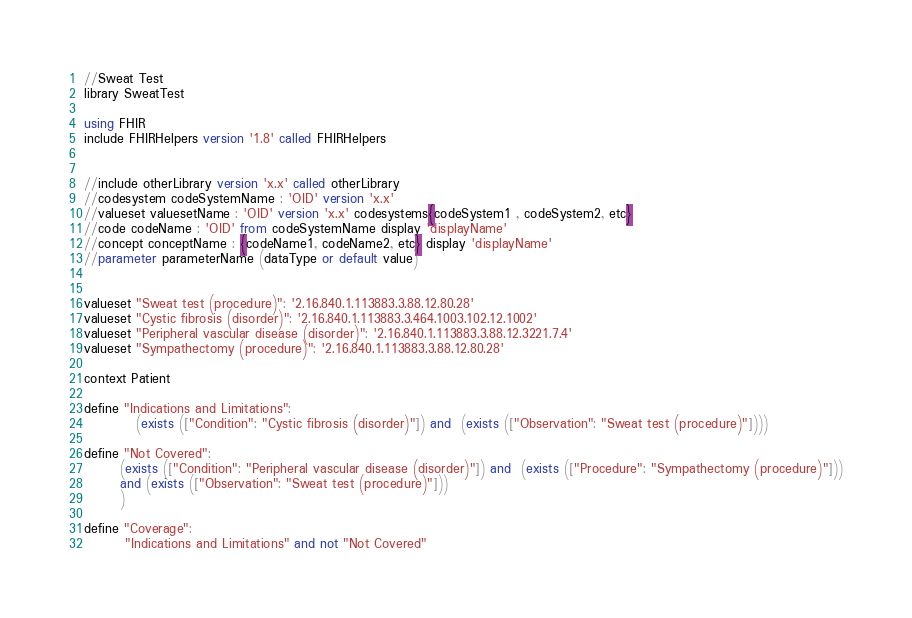<code> <loc_0><loc_0><loc_500><loc_500><_SQL_>//Sweat Test
library SweatTest

using FHIR
include FHIRHelpers version '1.8' called FHIRHelpers


//include otherLibrary version 'x.x' called otherLibrary
//codesystem codeSystemName : 'OID' version 'x.x'
//valueset valuesetName : 'OID' version 'x.x' codesystems{codeSystem1 , codeSystem2, etc}
//code codeName : 'OID' from codeSystemName display 'displayName'
//concept conceptName : {codeName1, codeName2, etc} display 'displayName'
//parameter parameterName (dataType or default value)


valueset "Sweat test (procedure)": '2.16.840.1.113883.3.88.12.80.28'
valueset "Cystic fibrosis (disorder)": '2.16.840.1.113883.3.464.1003.102.12.1002'
valueset "Peripheral vascular disease (disorder)": '2.16.840.1.113883.3.88.12.3221.7.4'
valueset "Sympathectomy (procedure)": '2.16.840.1.113883.3.88.12.80.28'

context Patient

define "Indications and Limitations":
          (exists (["Condition": "Cystic fibrosis (disorder)"]) and  (exists (["Observation": "Sweat test (procedure)"])))
          
define "Not Covered":
       (exists (["Condition": "Peripheral vascular disease (disorder)"]) and  (exists (["Procedure": "Sympathectomy (procedure)"]))
       and (exists (["Observation": "Sweat test (procedure)"]))
       )
       
define "Coverage":
        "Indications and Limitations" and not "Not Covered"
</code> 